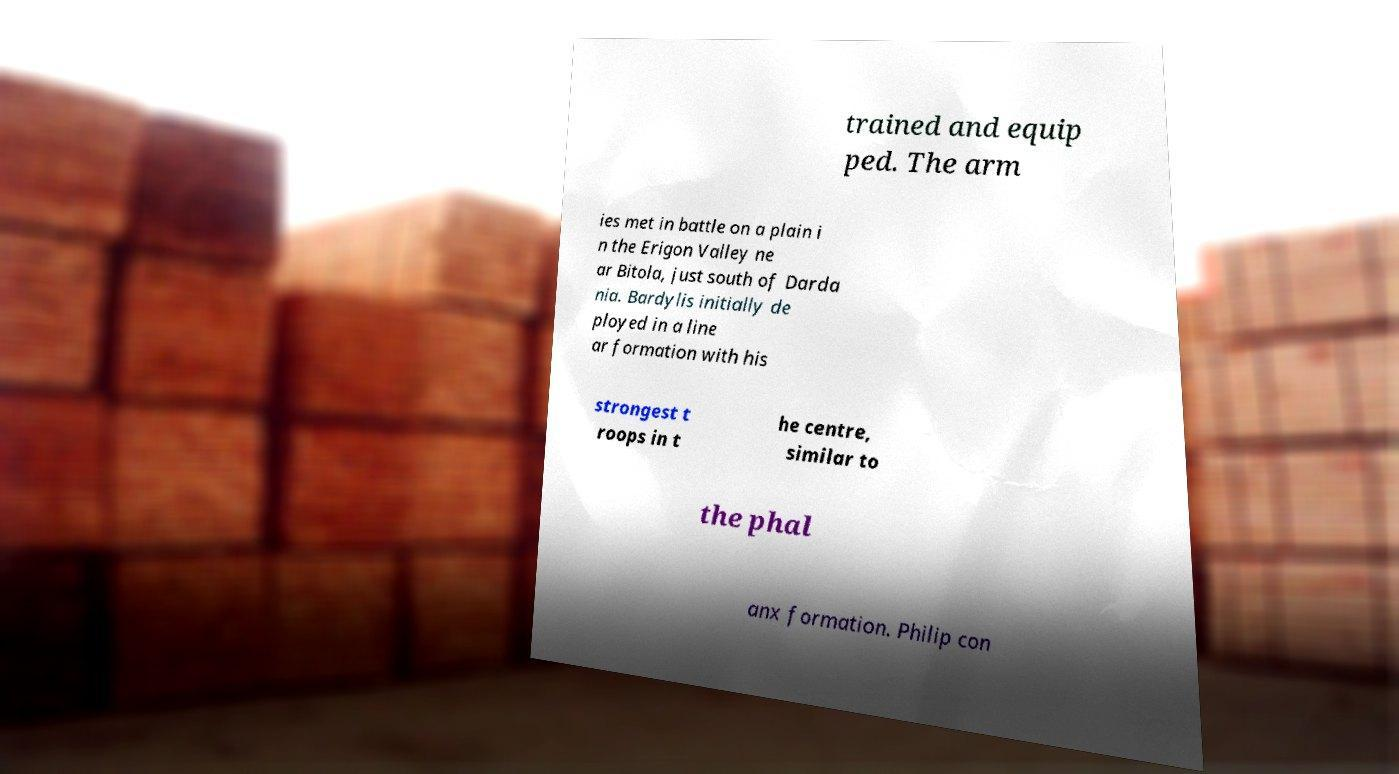There's text embedded in this image that I need extracted. Can you transcribe it verbatim? trained and equip ped. The arm ies met in battle on a plain i n the Erigon Valley ne ar Bitola, just south of Darda nia. Bardylis initially de ployed in a line ar formation with his strongest t roops in t he centre, similar to the phal anx formation. Philip con 